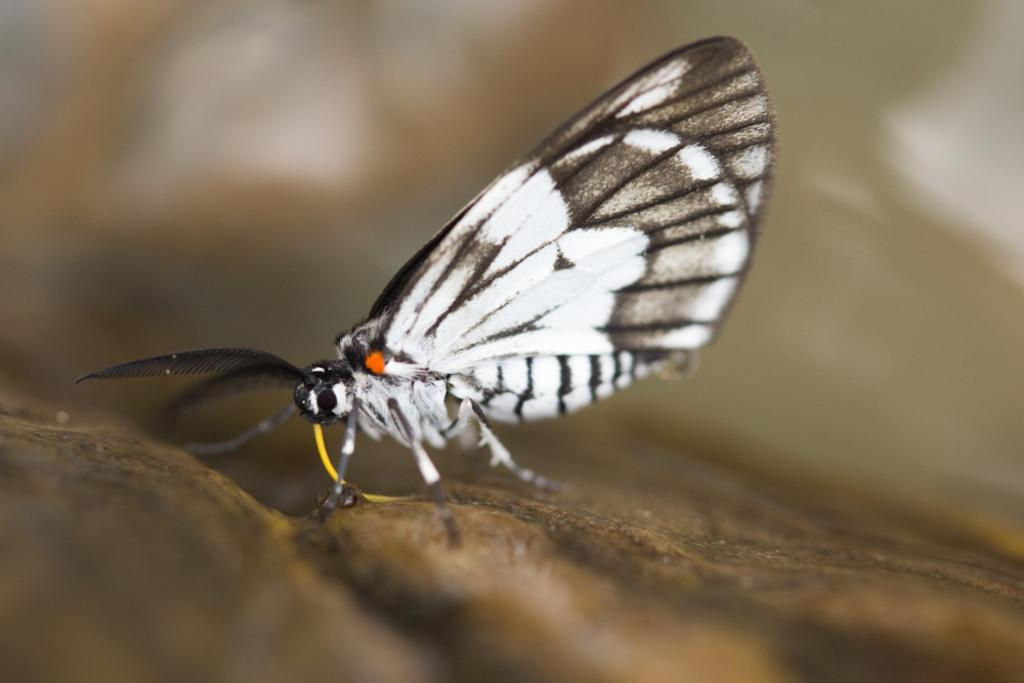What type of animal can be seen in the image? There is a butterfly in the image. Can you describe the background of the image? The background of the image is blurred. What type of breakfast is being served in the image? There is no breakfast present in the image; it features a butterfly and a blurred background. What level of comfort can be observed in the image? The image does not depict a scene or object that can be described in terms of comfort. 